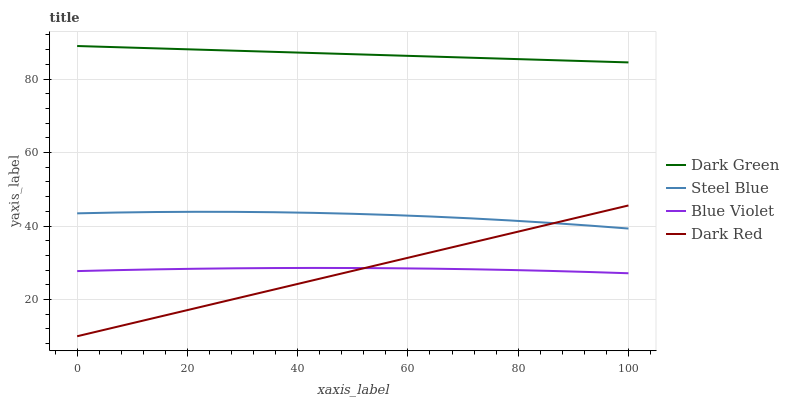Does Dark Red have the minimum area under the curve?
Answer yes or no. Yes. Does Dark Green have the maximum area under the curve?
Answer yes or no. Yes. Does Steel Blue have the minimum area under the curve?
Answer yes or no. No. Does Steel Blue have the maximum area under the curve?
Answer yes or no. No. Is Dark Red the smoothest?
Answer yes or no. Yes. Is Steel Blue the roughest?
Answer yes or no. Yes. Is Blue Violet the smoothest?
Answer yes or no. No. Is Blue Violet the roughest?
Answer yes or no. No. Does Dark Red have the lowest value?
Answer yes or no. Yes. Does Steel Blue have the lowest value?
Answer yes or no. No. Does Dark Green have the highest value?
Answer yes or no. Yes. Does Steel Blue have the highest value?
Answer yes or no. No. Is Steel Blue less than Dark Green?
Answer yes or no. Yes. Is Dark Green greater than Blue Violet?
Answer yes or no. Yes. Does Blue Violet intersect Dark Red?
Answer yes or no. Yes. Is Blue Violet less than Dark Red?
Answer yes or no. No. Is Blue Violet greater than Dark Red?
Answer yes or no. No. Does Steel Blue intersect Dark Green?
Answer yes or no. No. 